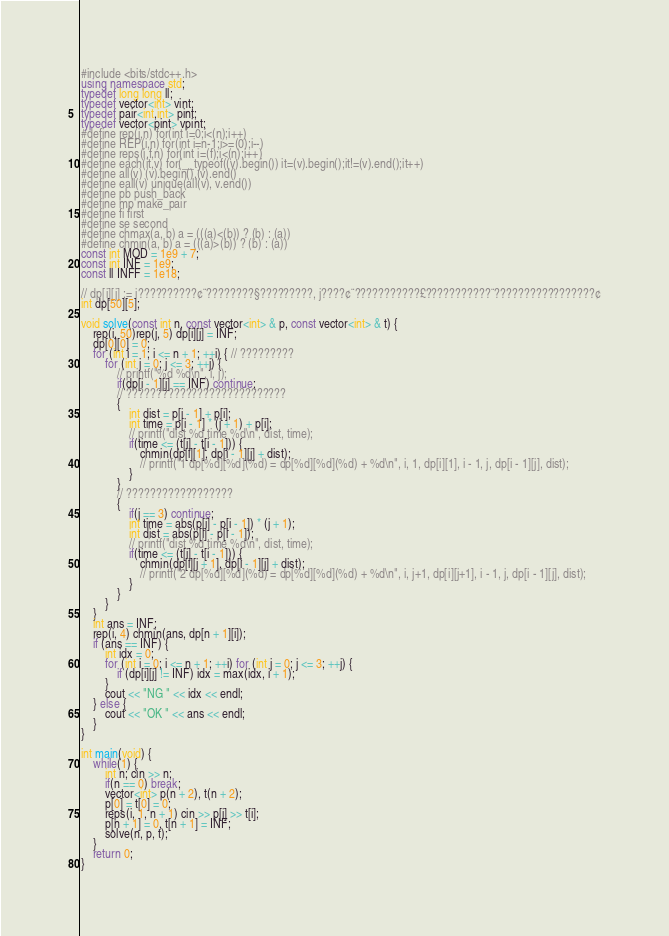<code> <loc_0><loc_0><loc_500><loc_500><_C++_>#include <bits/stdc++.h>
using namespace std;
typedef long long ll;
typedef vector<int> vint;
typedef pair<int,int> pint;
typedef vector<pint> vpint;
#define rep(i,n) for(int i=0;i<(n);i++)
#define REP(i,n) for(int i=n-1;i>=(0);i--)
#define reps(i,f,n) for(int i=(f);i<(n);i++)
#define each(it,v) for(__typeof((v).begin()) it=(v).begin();it!=(v).end();it++)
#define all(v) (v).begin(),(v).end()
#define eall(v) unique(all(v), v.end())
#define pb push_back
#define mp make_pair
#define fi first
#define se second
#define chmax(a, b) a = (((a)<(b)) ? (b) : (a))
#define chmin(a, b) a = (((a)>(b)) ? (b) : (a))
const int MOD = 1e9 + 7;
const int INF = 1e9;
const ll INFF = 1e18;

// dp[i][j] := i??????????¢¨????????§?????????, j????¢¨???????????£???????????¨?????????????????¢
int dp[50][5];

void solve(const int n, const vector<int> & p, const vector<int> & t) {
	rep(i, 50)rep(j, 5) dp[i][j] = INF;
	dp[0][0] = 0;
	for (int i = 1; i <= n + 1; ++i) { // ?????????
		for (int j = 0; j <= 3; ++j) {
			// printf("%d %d\n", i, j);
			if(dp[i - 1][j] == INF) continue;
			// ???????????????????????????
			{
				int dist = p[i - 1] + p[i];
				int time = p[i - 1] * (j + 1) + p[i];
				// printf("dist %d time %d\n", dist, time);
				if(time <= (t[i] - t[i - 1])) {
					chmin(dp[i][1], dp[i - 1][j] + dist);
					// printf("1 dp[%d][%d](%d) = dp[%d][%d](%d) + %d\n", i, 1, dp[i][1], i - 1, j, dp[i - 1][j], dist);
				}
			}
			// ??????????????????
			{
				if(j == 3) continue;
				int time = abs(p[i] - p[i - 1]) * (j + 1);
				int dist = abs(p[i] - p[i - 1]);
				// printf("dist %d time %d\n", dist, time);
				if(time <= (t[i] - t[i - 1])) {
					chmin(dp[i][j + 1], dp[i - 1][j] + dist);
					// printf("2 dp[%d][%d](%d) = dp[%d][%d](%d) + %d\n", i, j+1, dp[i][j+1], i - 1, j, dp[i - 1][j], dist);
				}
			}
		}
	}
	int ans = INF;
	rep(i, 4) chmin(ans, dp[n + 1][i]);
	if (ans == INF) {
		int idx = 0;
		for (int i = 0; i <= n + 1; ++i) for (int j = 0; j <= 3; ++j) {
			if (dp[i][j] != INF) idx = max(idx, i + 1);
		}
		cout << "NG " << idx << endl;
	} else {
		cout << "OK " << ans << endl;
	}
}

int main(void) {
	while(1) {
		int n; cin >> n;
		if(n == 0) break;
		vector<int> p(n + 2), t(n + 2);
		p[0] = t[0] = 0;
		reps(i, 1, n + 1) cin >> p[i] >> t[i];
		p[n + 1] = 0, t[n + 1] = INF;
		solve(n, p, t);
	}
	return 0;
}</code> 